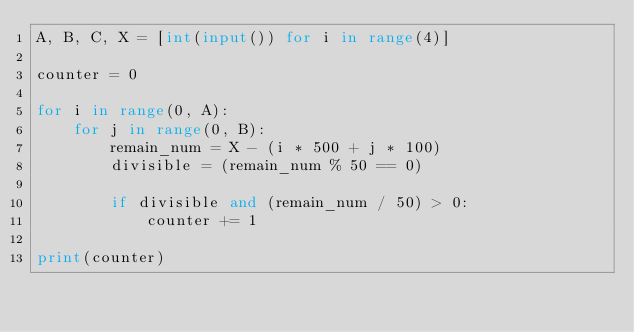<code> <loc_0><loc_0><loc_500><loc_500><_Python_>A, B, C, X = [int(input()) for i in range(4)]

counter = 0

for i in range(0, A):
    for j in range(0, B):
        remain_num = X - (i * 500 + j * 100)
        divisible = (remain_num % 50 == 0)

        if divisible and (remain_num / 50) > 0:
            counter += 1

print(counter)
</code> 